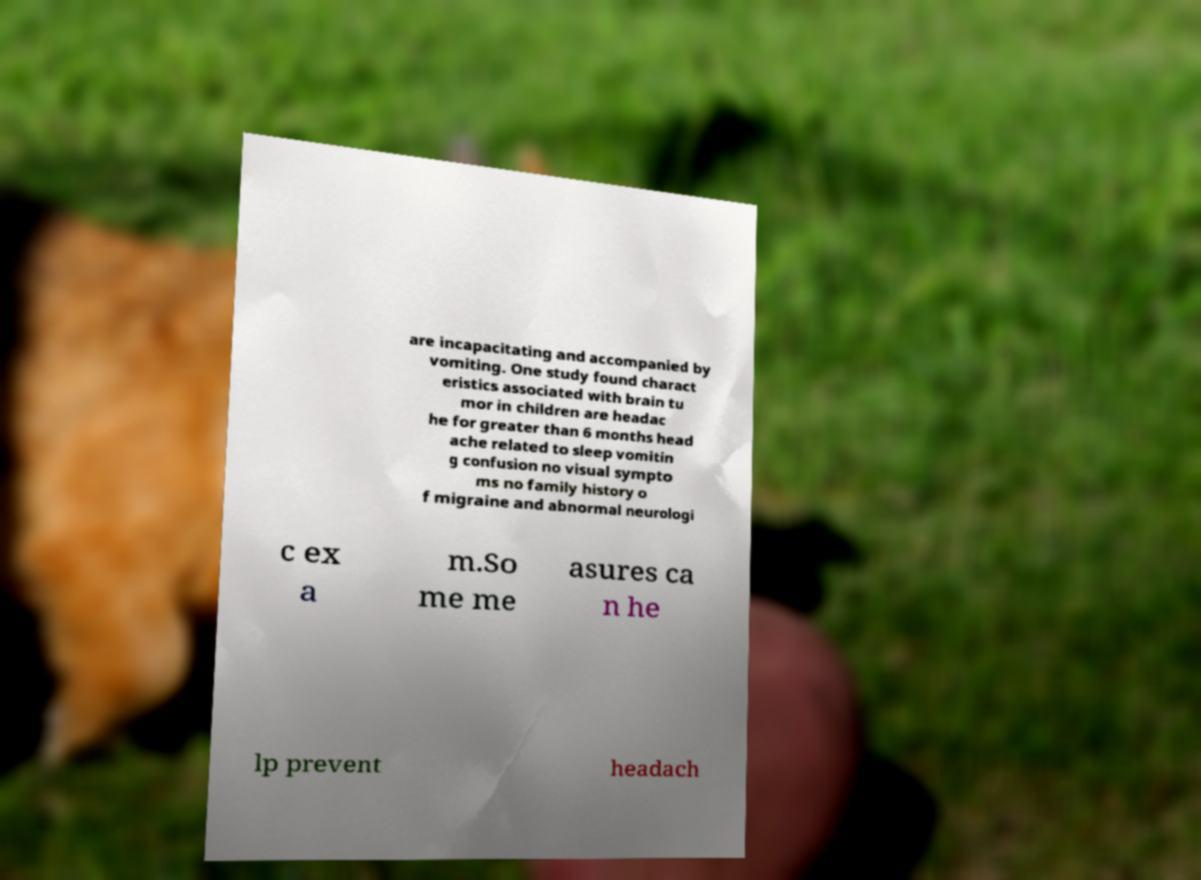There's text embedded in this image that I need extracted. Can you transcribe it verbatim? are incapacitating and accompanied by vomiting. One study found charact eristics associated with brain tu mor in children are headac he for greater than 6 months head ache related to sleep vomitin g confusion no visual sympto ms no family history o f migraine and abnormal neurologi c ex a m.So me me asures ca n he lp prevent headach 